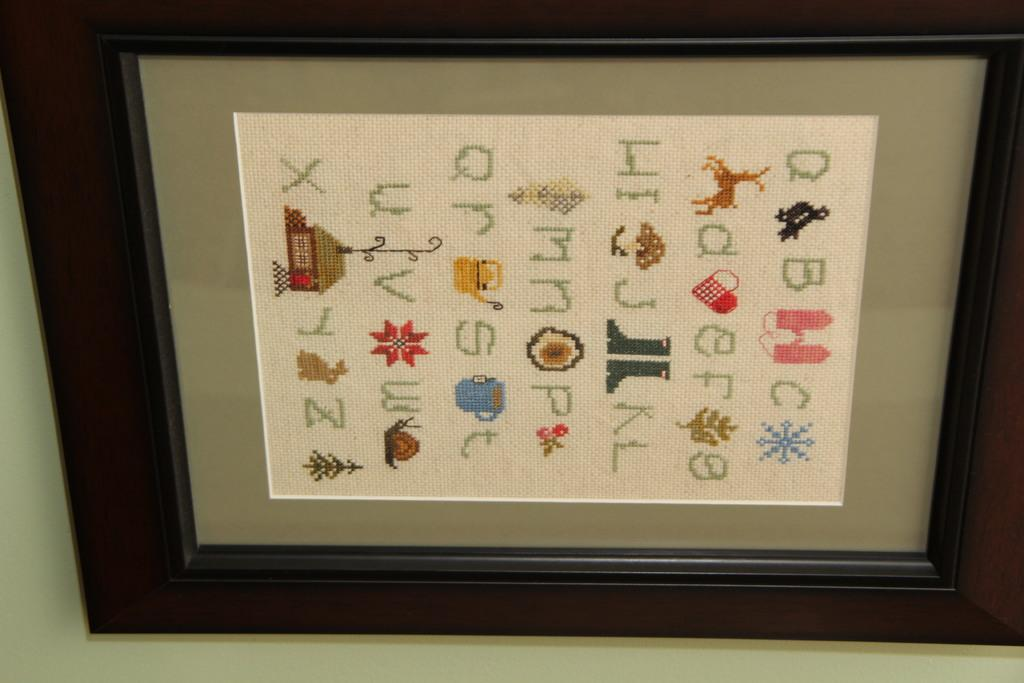<image>
Write a terse but informative summary of the picture. a picture with pictures and some letter such as Q R S T on it. 